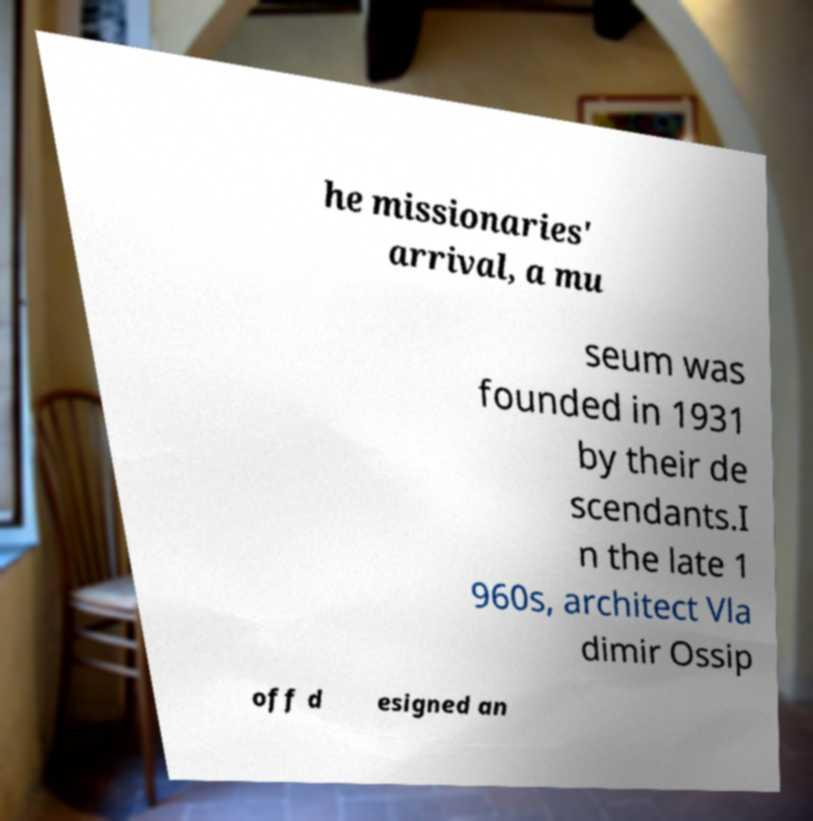Could you extract and type out the text from this image? he missionaries' arrival, a mu seum was founded in 1931 by their de scendants.I n the late 1 960s, architect Vla dimir Ossip off d esigned an 